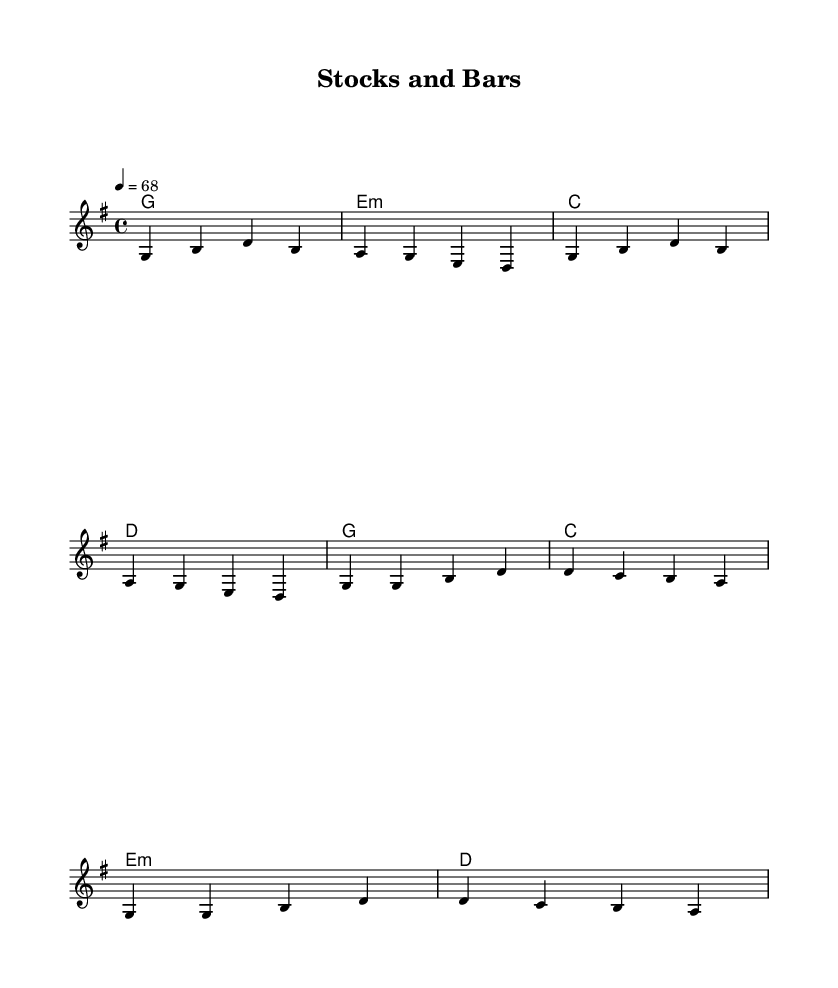What is the key signature of this music? The key signature in the sheet music indicates that it is in G major, which has one sharp (F#).
Answer: G major What is the time signature of this music? The time signature shown in the sheet music is 4/4, which means there are four beats in each measure.
Answer: 4/4 What is the tempo marking? The tempo marking in the sheet music indicates that the piece should be played at a speed of 68 beats per minute.
Answer: 68 What are the main chords used in the verses? The chords for the verses are G, E minor, C, and D as indicated in the chord mode.
Answer: G, E minor, C, D How many measures are there in the chorus? The chorus section is composed of two lines, each with four beats, making it a total of 8 measures.
Answer: 8 measures What emotional theme is reflected in the lyrics? The lyrics convey a sense of regret and reflection on past mistakes, centered around greed and freedom.
Answer: Regret and reflection What is the primary lyrical focus of the ballad? The main focus of the lyrics discusses the regrets of past ambitions in finance and the loss that stems from them.
Answer: Lost ambitions 